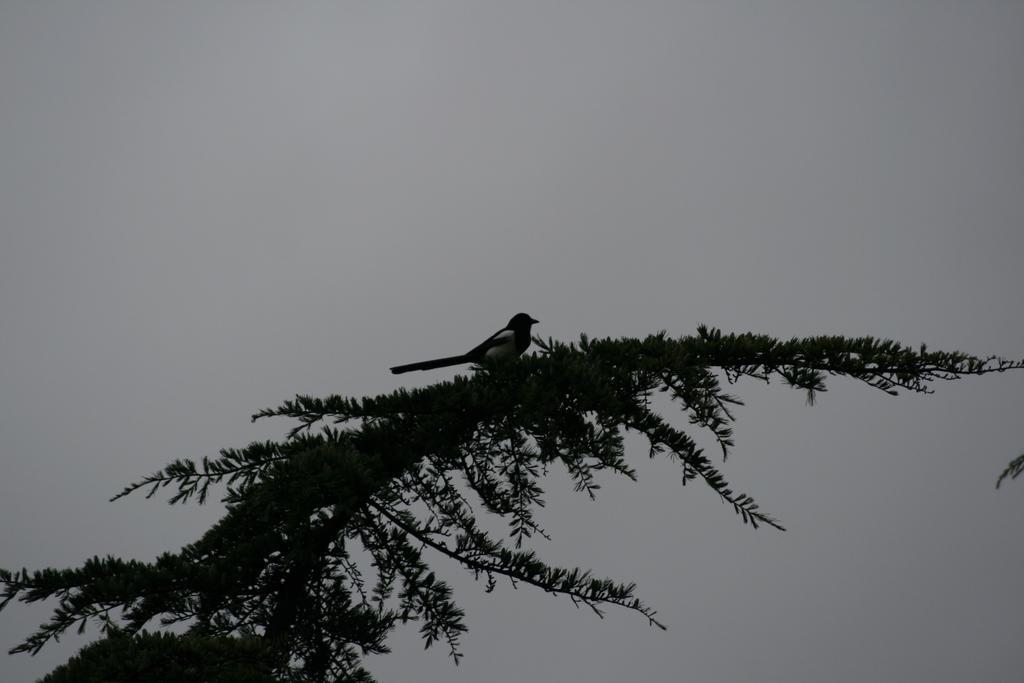Could you give a brief overview of what you see in this image? Here in this picture we can see a bird represent on a plant over there. 